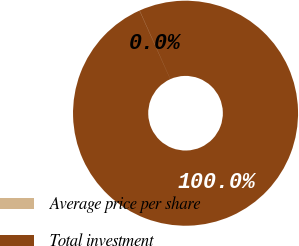Convert chart. <chart><loc_0><loc_0><loc_500><loc_500><pie_chart><fcel>Average price per share<fcel>Total investment<nl><fcel>0.02%<fcel>99.98%<nl></chart> 